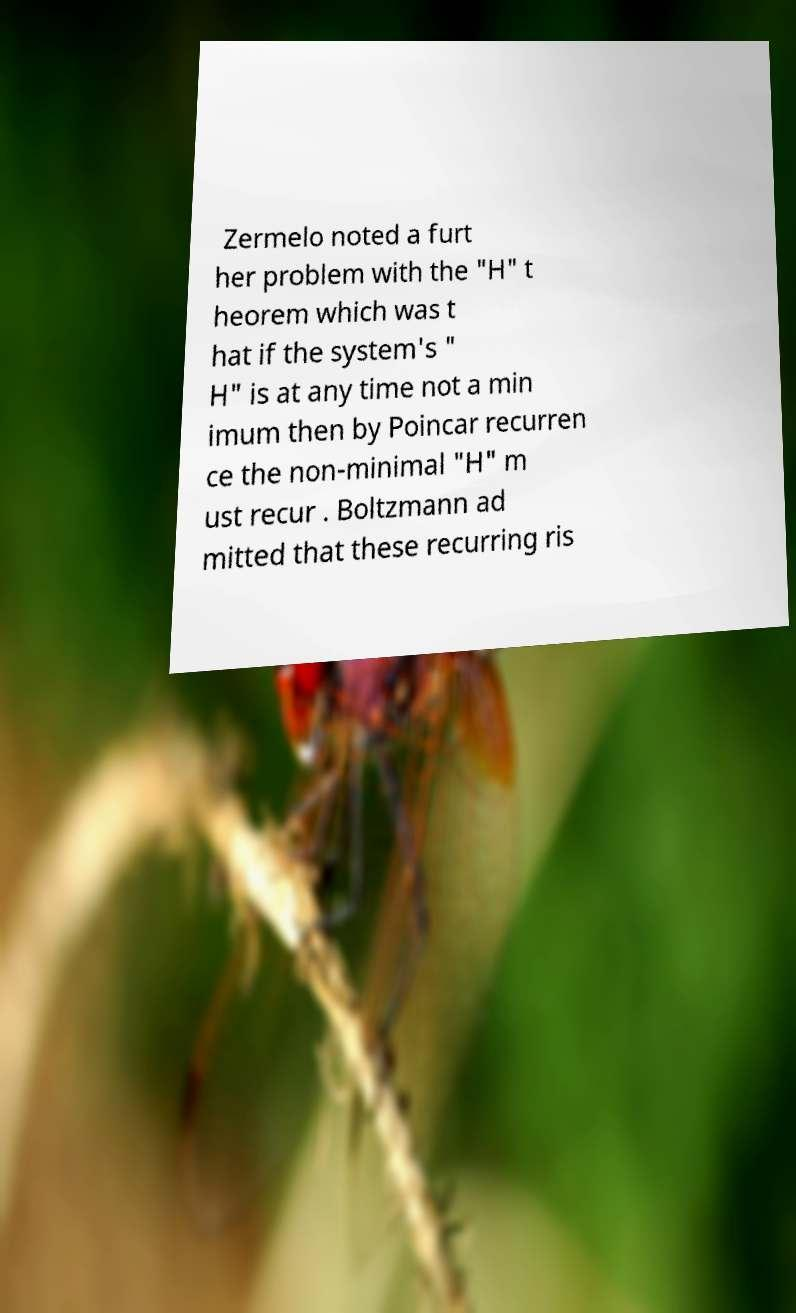I need the written content from this picture converted into text. Can you do that? Zermelo noted a furt her problem with the "H" t heorem which was t hat if the system's " H" is at any time not a min imum then by Poincar recurren ce the non-minimal "H" m ust recur . Boltzmann ad mitted that these recurring ris 